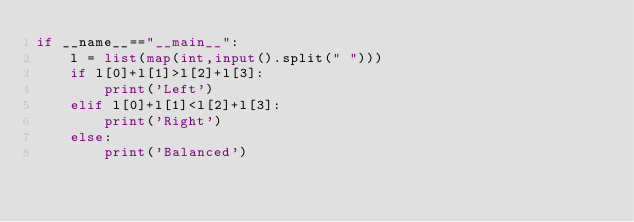<code> <loc_0><loc_0><loc_500><loc_500><_Python_>if __name__=="__main__":
    l = list(map(int,input().split(" ")))
    if l[0]+l[1]>l[2]+l[3]:
        print('Left')
    elif l[0]+l[1]<l[2]+l[3]:
        print('Right')
    else:
        print('Balanced')</code> 